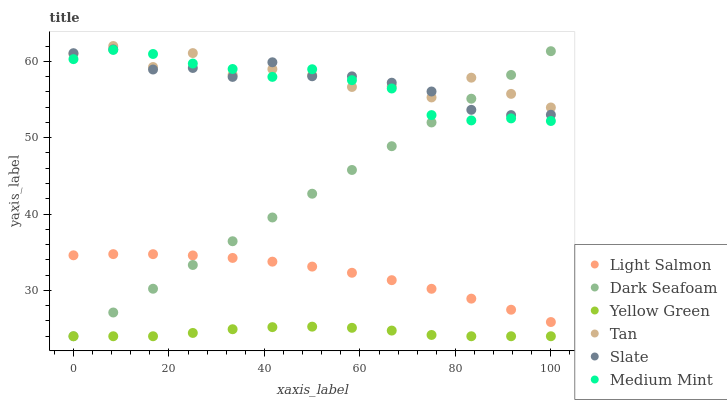Does Yellow Green have the minimum area under the curve?
Answer yes or no. Yes. Does Tan have the maximum area under the curve?
Answer yes or no. Yes. Does Light Salmon have the minimum area under the curve?
Answer yes or no. No. Does Light Salmon have the maximum area under the curve?
Answer yes or no. No. Is Dark Seafoam the smoothest?
Answer yes or no. Yes. Is Tan the roughest?
Answer yes or no. Yes. Is Light Salmon the smoothest?
Answer yes or no. No. Is Light Salmon the roughest?
Answer yes or no. No. Does Yellow Green have the lowest value?
Answer yes or no. Yes. Does Light Salmon have the lowest value?
Answer yes or no. No. Does Tan have the highest value?
Answer yes or no. Yes. Does Light Salmon have the highest value?
Answer yes or no. No. Is Light Salmon less than Tan?
Answer yes or no. Yes. Is Tan greater than Light Salmon?
Answer yes or no. Yes. Does Dark Seafoam intersect Slate?
Answer yes or no. Yes. Is Dark Seafoam less than Slate?
Answer yes or no. No. Is Dark Seafoam greater than Slate?
Answer yes or no. No. Does Light Salmon intersect Tan?
Answer yes or no. No. 